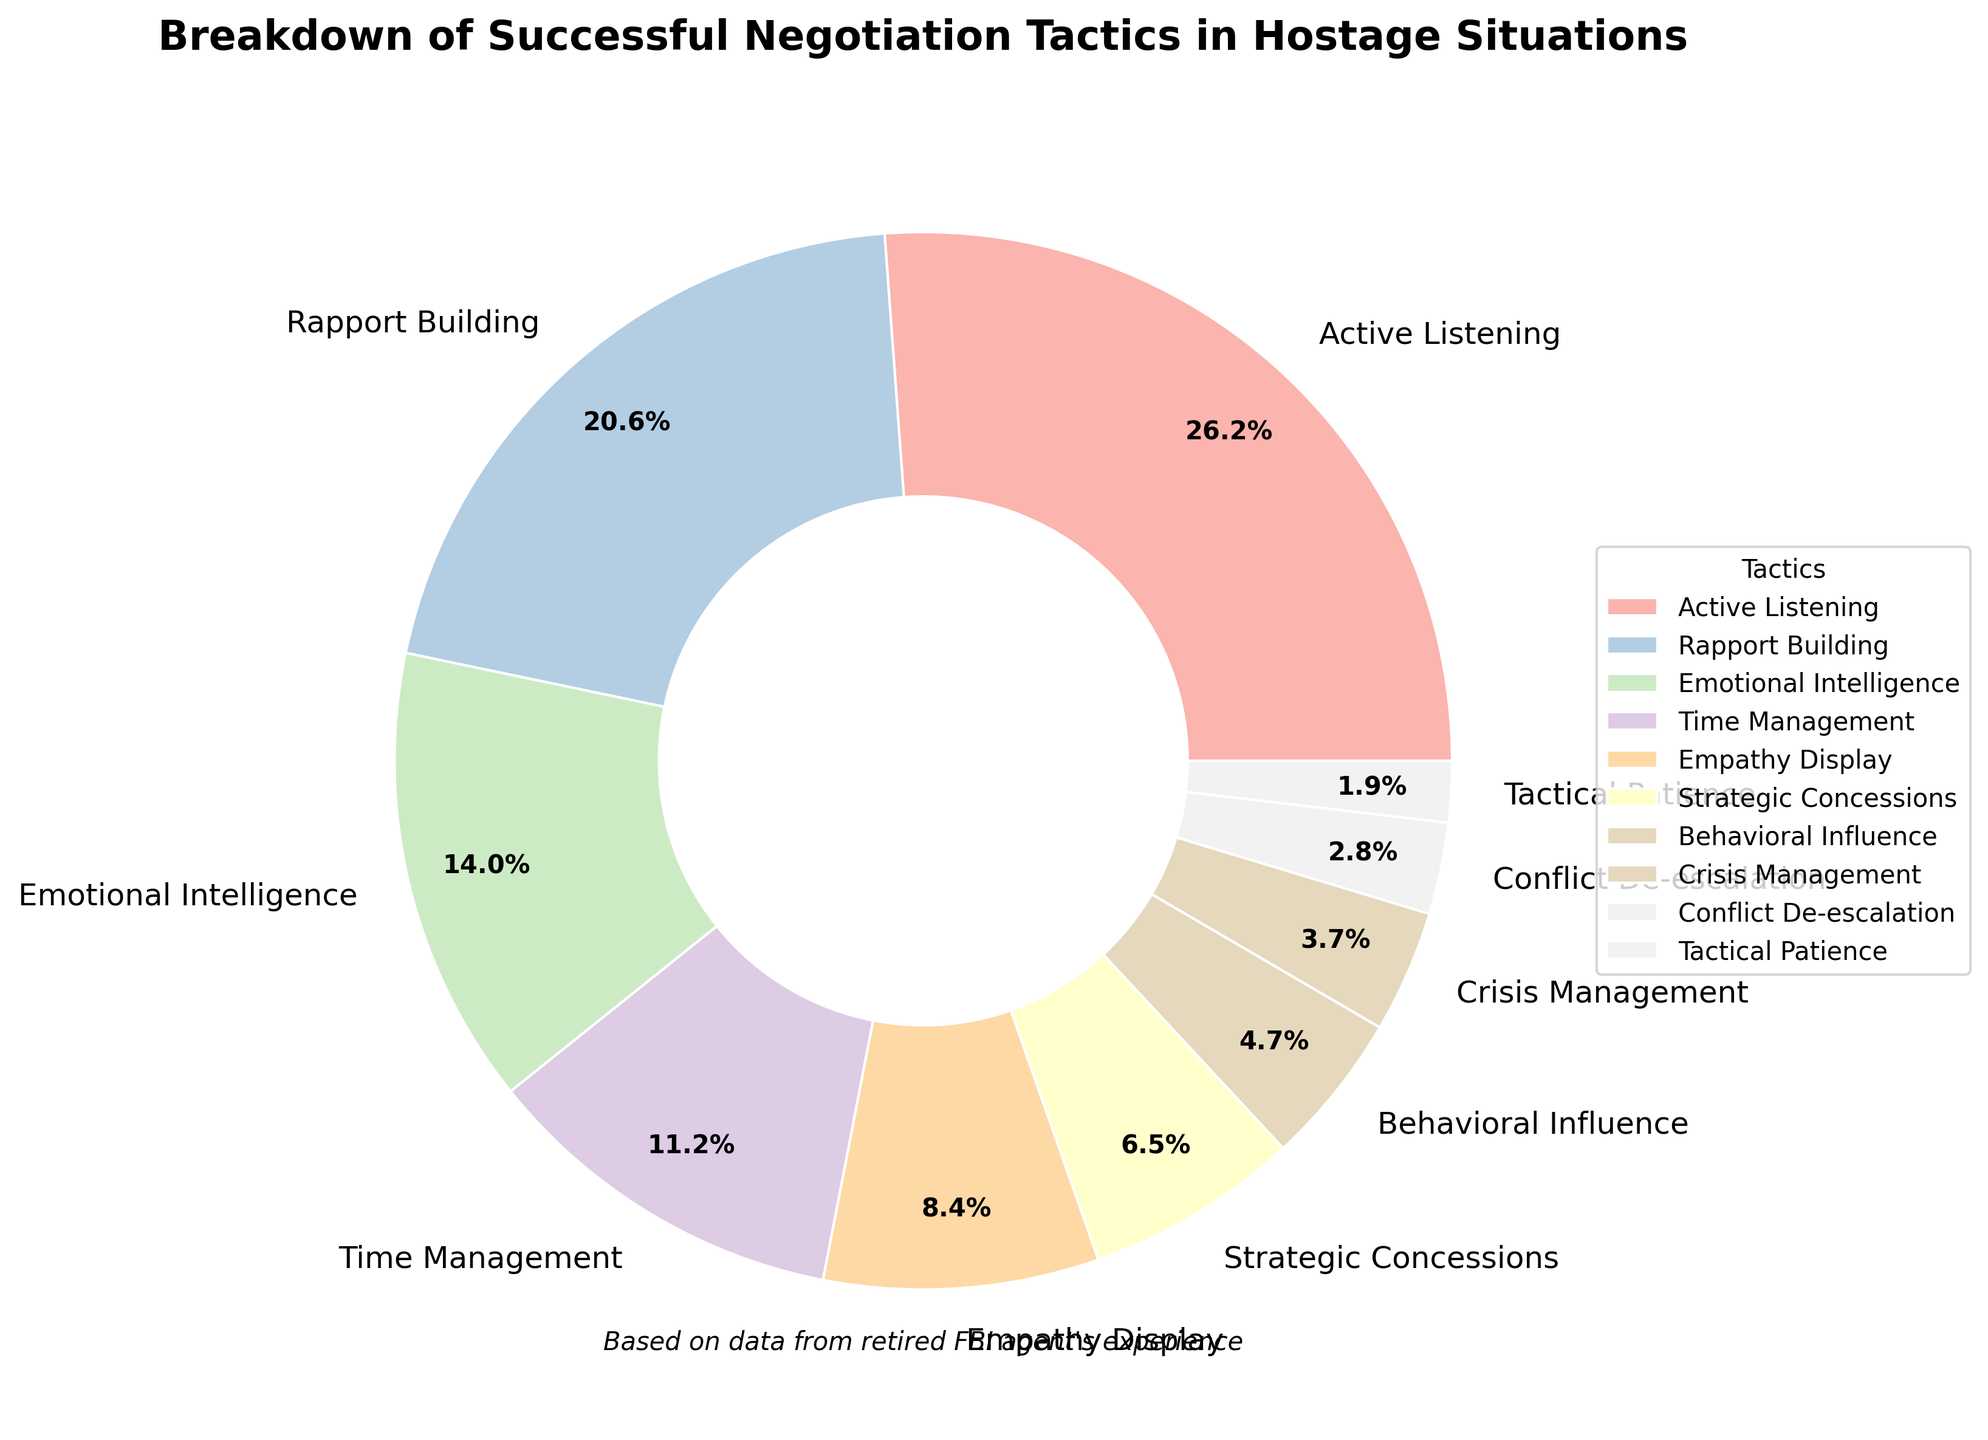which tactic has the highest percentage? Locate the section with the largest portion visually and read its label. "Active Listening" has the largest slice.
Answer: Active Listening how many tactics have a percentage of 10% or more? Count the number of sections where the percentage is 10% or greater. These are Active Listening, Rapport Building, and Emotional Intelligence.
Answer: 3 what is the combined percentage of empathy display and strategic concessions? Add the percentages of Empathy Display (9%) and Strategic Concessions (7%). 9% + 7% = 16%.
Answer: 16% which tactic has the smallest percentage? Find the section with the smallest portion visually and read its label. "Tactical Patience" has the smallest slice.
Answer: Tactical Patience what percentage of tactics contribute less than 10%? Identify the tactics contributing less than 10%: Empathy Display, Strategic Concessions, Behavioral Influence, Crisis Management, Conflict De-escalation, and Tactical Patience. Count them.
Answer: 6 is the percentage of rapport building greater or smaller than that of emotional intelligence? Refer to the chart and compare the percentage of Rapport Building (22%) with Emotional Intelligence (15%).
Answer: Greater what is the difference in percentage between active listening and time management? Subtract the percentage of Time Management (12%) from Active Listening (28%). 28% - 12% = 16%.
Answer: 16% which tactic occupies the fourth largest portion of the pie chart? Identify the sections with the largest, second, third, and fourth-largest portions visually. The fourth largest is Time Management (12%).
Answer: Time Management do the combined percentages of conflict de-escalation and crisis management exceed that of behavioral influence? Add the percentages of Conflict De-escalation (3%) and Crisis Management (4%), then compare the sum with Behavioral Influence (5%). 3% + 4% = 7%, which is greater than 5%.
Answer: Yes what is the ratio of active listening to tactical patience in terms of percentage? Divide the percentage of Active Listening (28%) by Tactical Patience (2%). 28 / 2 = 14.
Answer: 14 